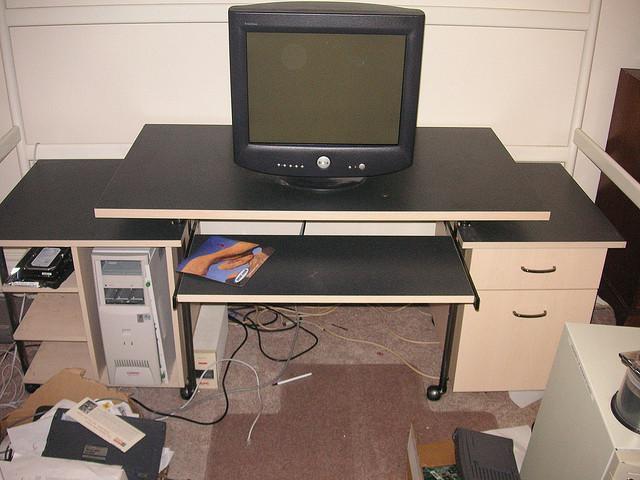How many drawers are there?
Give a very brief answer. 2. How many people are lying down underneath the truck?
Give a very brief answer. 0. 